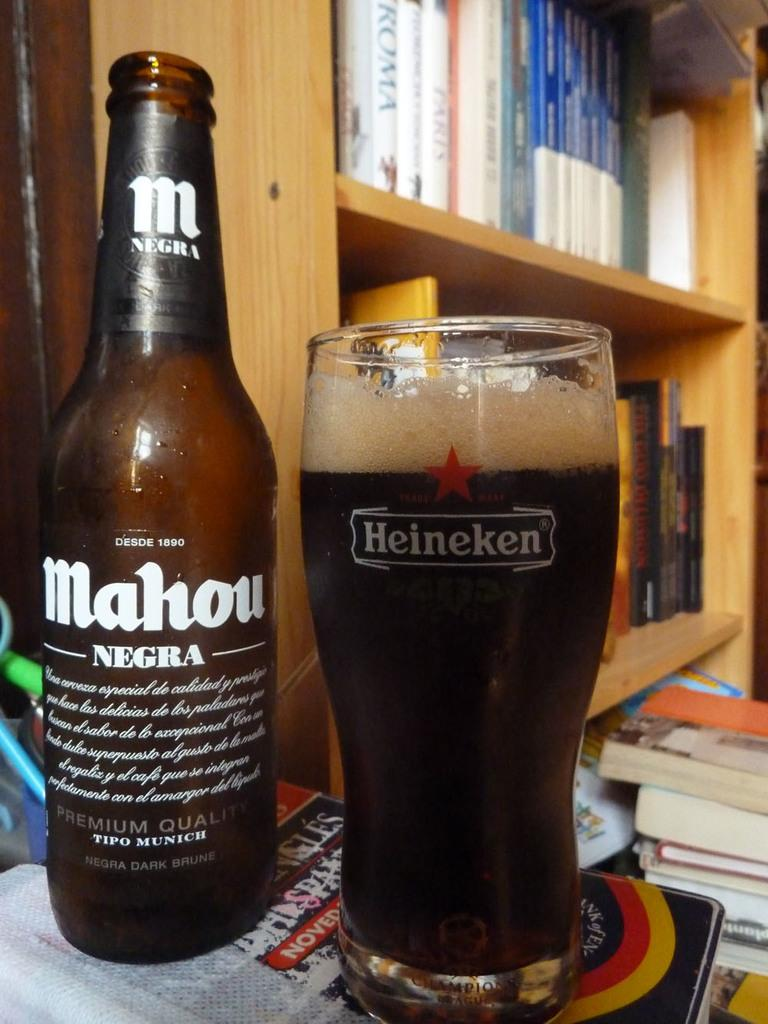Provide a one-sentence caption for the provided image. A bottle of Mahou Negra is next to a Heineken glass filled with the beer. 